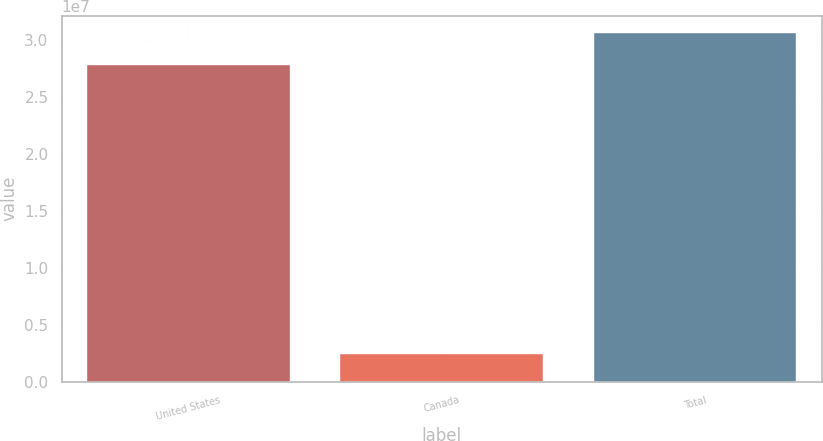Convert chart. <chart><loc_0><loc_0><loc_500><loc_500><bar_chart><fcel>United States<fcel>Canada<fcel>Total<nl><fcel>2.78509e+07<fcel>2.43099e+06<fcel>3.0636e+07<nl></chart> 